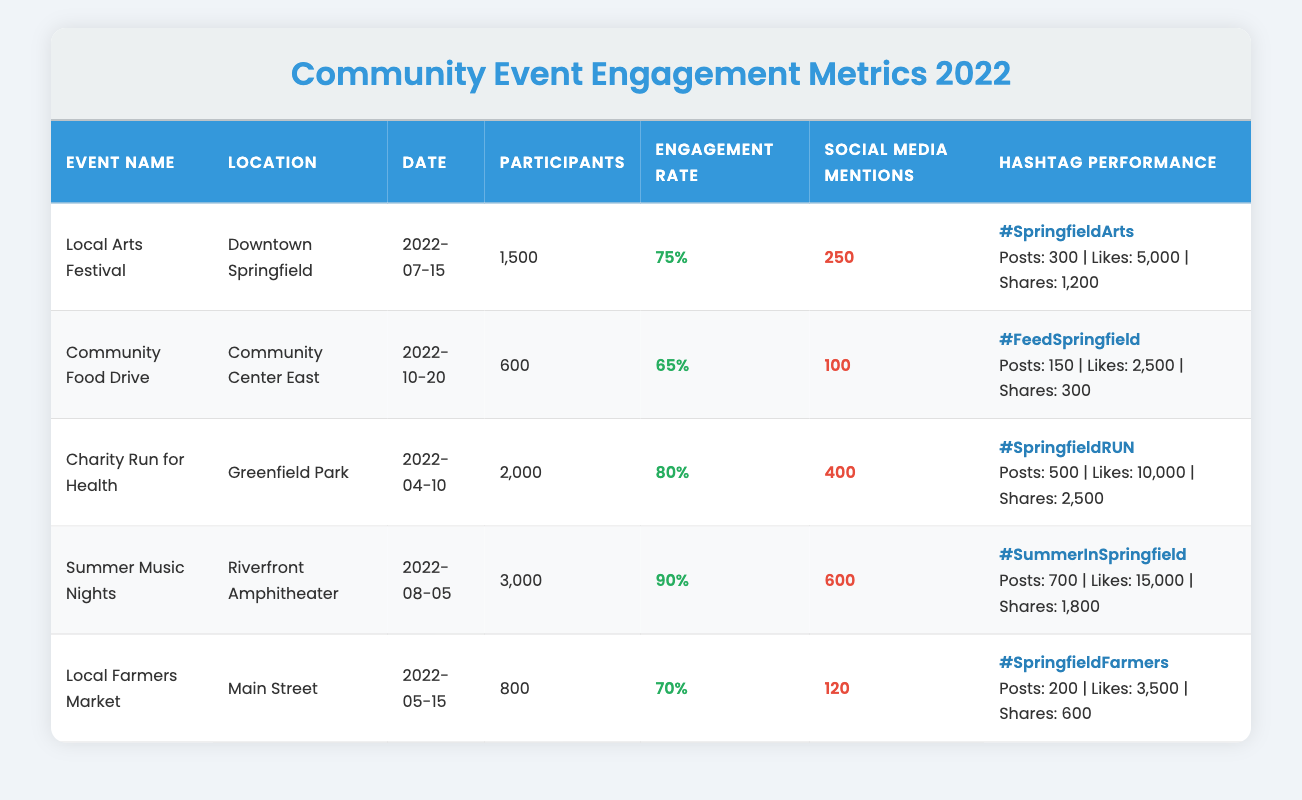What is the engagement rate for the Local Arts Festival? The engagement rate for the Local Arts Festival is provided in the table as 75%.
Answer: 75% How many participants attended the Summer Music Nights? The number of participants for the Summer Music Nights is directly listed in the table as 3000.
Answer: 3000 Which event had the highest social media mentions? By comparing the social media mentions across all events, the Summer Music Nights have the highest at 600 mentions.
Answer: Summer Music Nights What is the average engagement rate of all events listed? To find the average engagement rate, sum the engagement rates: (0.75 + 0.65 + 0.80 + 0.90 + 0.70) = 3.70. There are 5 events, so the average is 3.70 / 5 = 0.74 or 74%.
Answer: 74% Did the Community Food Drive have more participants than the Local Farmers Market? The Community Food Drive had 600 participants, while the Local Farmers Market had 800 participants. Since 600 is less than 800, the statement is false.
Answer: No Which event took place on October 20, 2022? The table shows that the Community Food Drive occurred on that date.
Answer: Community Food Drive What is the total number of participants from all events combined? Adding all participants: 1500 (Local Arts Festival) + 600 (Community Food Drive) + 2000 (Charity Run for Health) + 3000 (Summer Music Nights) + 800 (Local Farmers Market) = 8000 participants total.
Answer: 8000 Which hashtag had the most likes? Comparing the likes from each hashtag in the table, the hashtag #SummerInSpringfield garnered the most likes, with a total of 15000 likes.
Answer: #SummerInSpringfield Is the engagement rate for the Charity Run for Health higher than for the Local Farmers Market? The engagement rate for the Charity Run for Health is 80%, while the Local Farmers Market has an engagement rate of 70%. Since 80% is greater than 70%, the statement is true.
Answer: Yes What event had the lowest social media mentions among those listed? Upon reviewing the social media mentions, the Community Food Drive had the lowest count with only 100 mentions.
Answer: Community Food Drive 